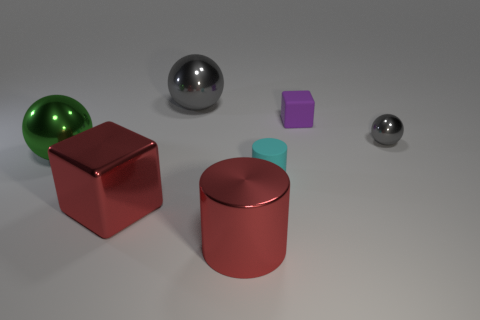Subtract all big green balls. How many balls are left? 2 Subtract all yellow cylinders. How many gray balls are left? 2 Subtract 1 spheres. How many spheres are left? 2 Add 2 red things. How many objects exist? 9 Subtract all brown spheres. Subtract all blue blocks. How many spheres are left? 3 Subtract 1 cyan cylinders. How many objects are left? 6 Subtract all blocks. How many objects are left? 5 Subtract all big green metal balls. Subtract all small gray objects. How many objects are left? 5 Add 6 big gray metallic objects. How many big gray metallic objects are left? 7 Add 4 cyan rubber cylinders. How many cyan rubber cylinders exist? 5 